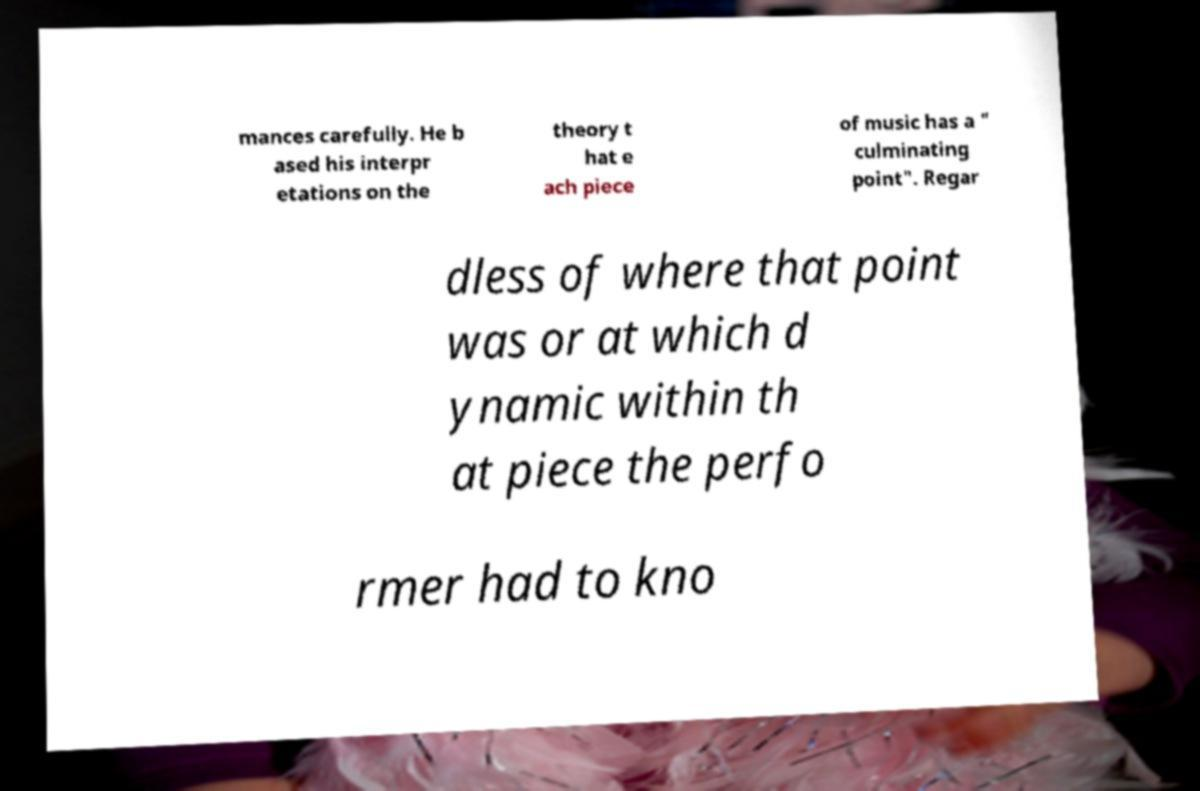Can you read and provide the text displayed in the image?This photo seems to have some interesting text. Can you extract and type it out for me? mances carefully. He b ased his interpr etations on the theory t hat e ach piece of music has a " culminating point". Regar dless of where that point was or at which d ynamic within th at piece the perfo rmer had to kno 